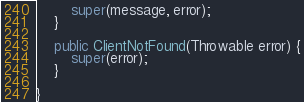<code> <loc_0><loc_0><loc_500><loc_500><_Java_>		super(message, error);
	}
	
	public ClientNotFound(Throwable error) {
		super(error);
	}
	
}
</code> 